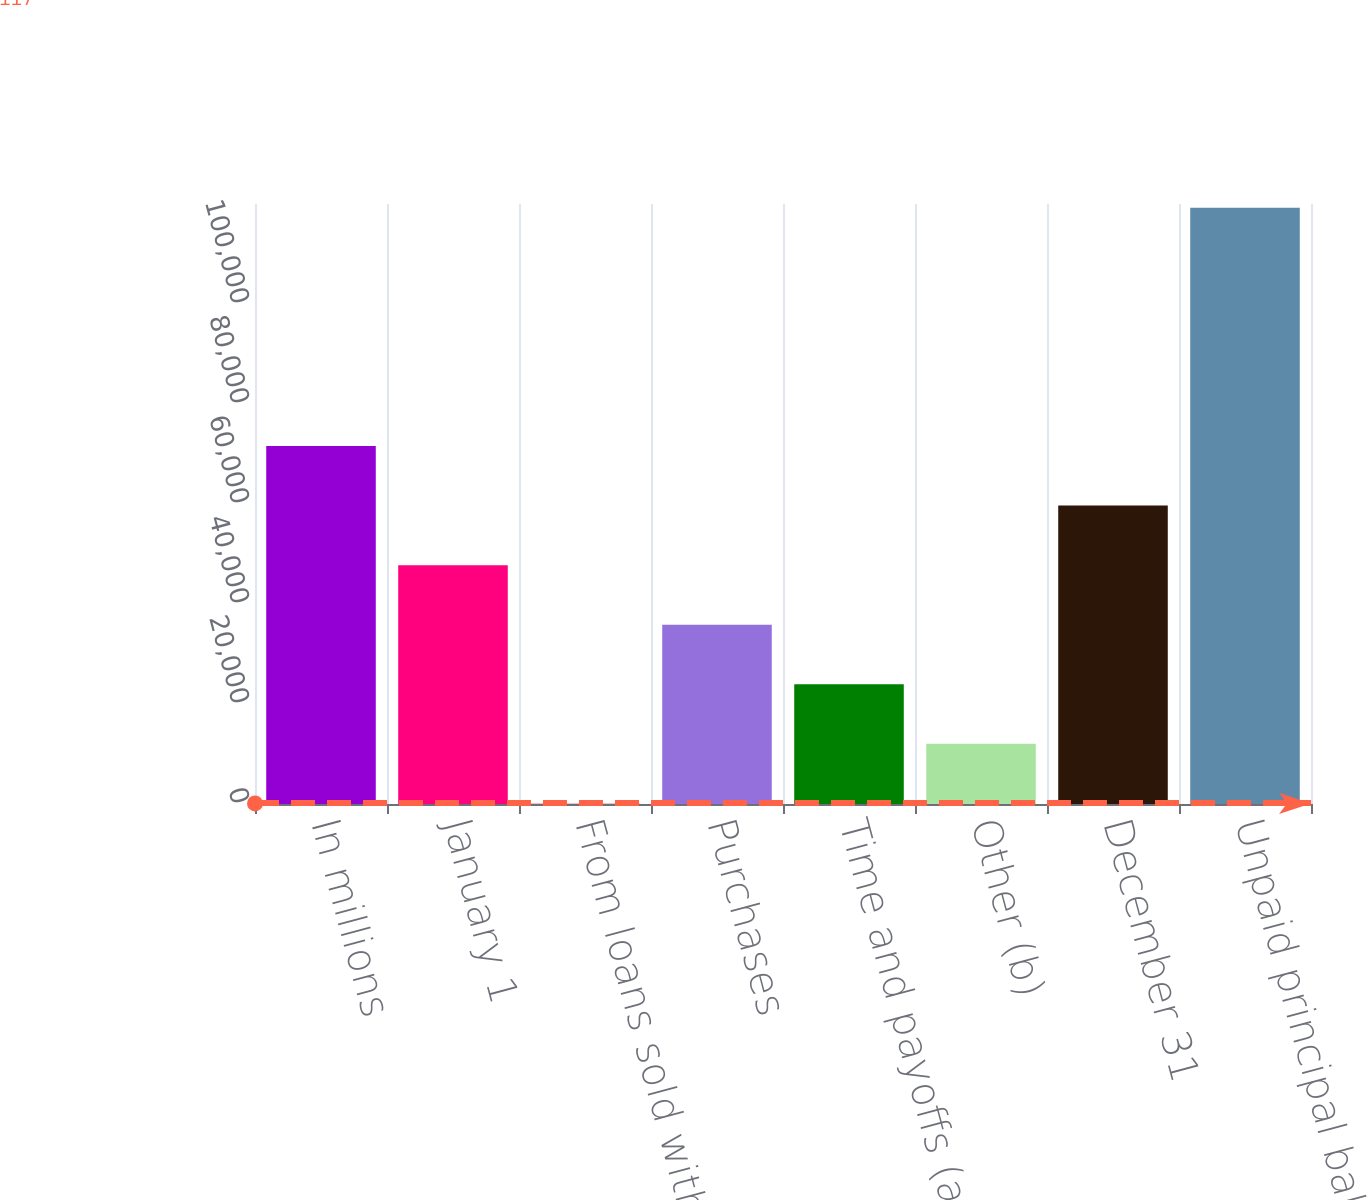Convert chart. <chart><loc_0><loc_0><loc_500><loc_500><bar_chart><fcel>In millions<fcel>January 1<fcel>From loans sold with servicing<fcel>Purchases<fcel>Time and payoffs (a)<fcel>Other (b)<fcel>December 31<fcel>Unpaid principal balance of<nl><fcel>71604<fcel>47775<fcel>117<fcel>35860.5<fcel>23946<fcel>12031.5<fcel>59689.5<fcel>119262<nl></chart> 